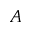<formula> <loc_0><loc_0><loc_500><loc_500>A</formula> 